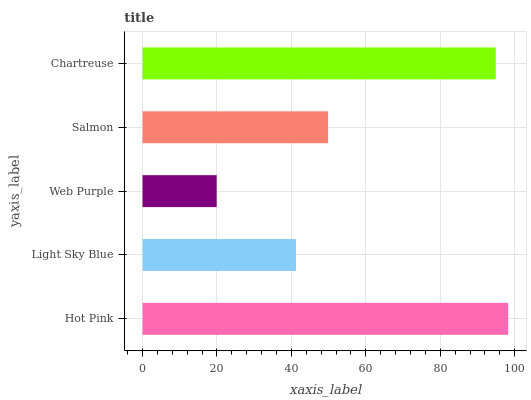Is Web Purple the minimum?
Answer yes or no. Yes. Is Hot Pink the maximum?
Answer yes or no. Yes. Is Light Sky Blue the minimum?
Answer yes or no. No. Is Light Sky Blue the maximum?
Answer yes or no. No. Is Hot Pink greater than Light Sky Blue?
Answer yes or no. Yes. Is Light Sky Blue less than Hot Pink?
Answer yes or no. Yes. Is Light Sky Blue greater than Hot Pink?
Answer yes or no. No. Is Hot Pink less than Light Sky Blue?
Answer yes or no. No. Is Salmon the high median?
Answer yes or no. Yes. Is Salmon the low median?
Answer yes or no. Yes. Is Chartreuse the high median?
Answer yes or no. No. Is Web Purple the low median?
Answer yes or no. No. 